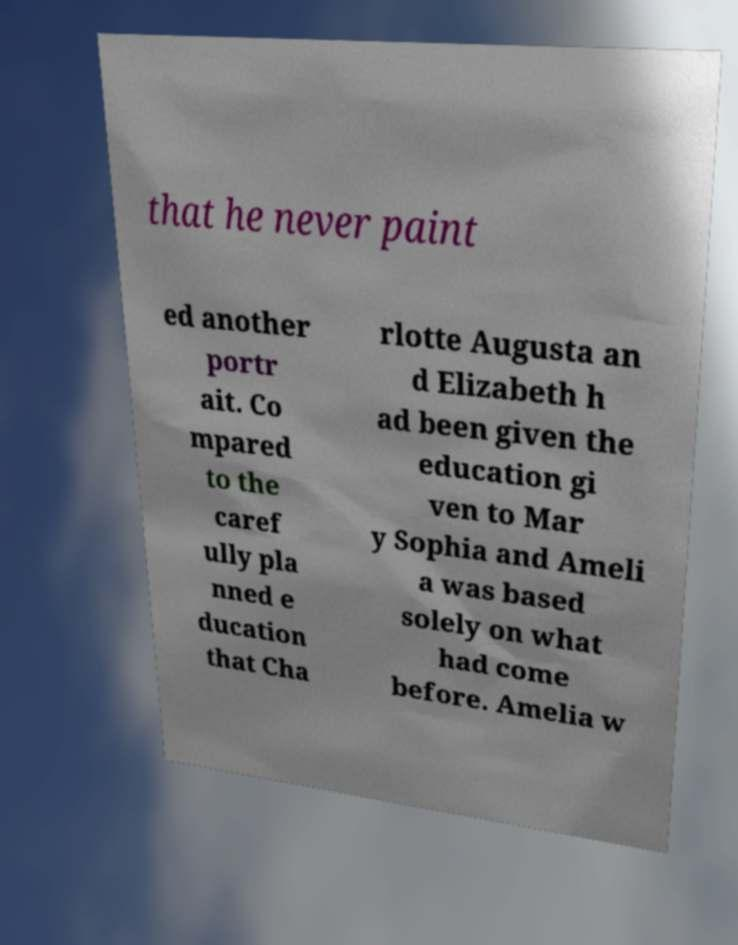There's text embedded in this image that I need extracted. Can you transcribe it verbatim? that he never paint ed another portr ait. Co mpared to the caref ully pla nned e ducation that Cha rlotte Augusta an d Elizabeth h ad been given the education gi ven to Mar y Sophia and Ameli a was based solely on what had come before. Amelia w 